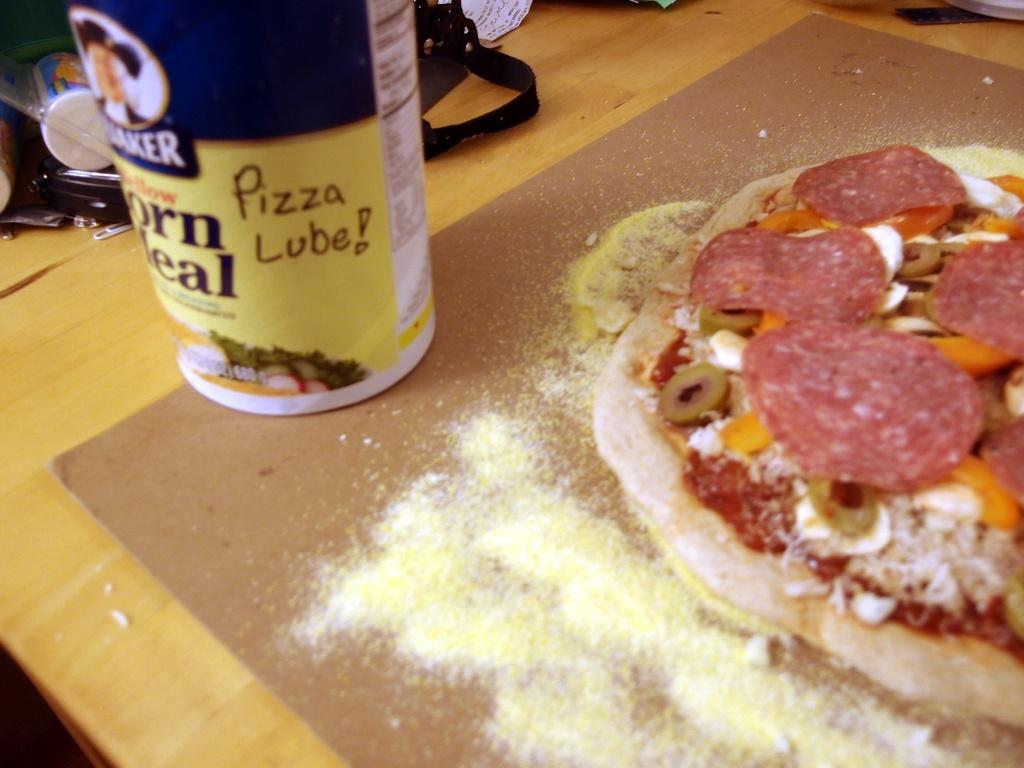What is located at the bottom of the image? There is a board at the bottom of the image. What is on top of the board? There is a pizza and a bottle on the board. Can you describe any objects visible in the background of the image? Unfortunately, the provided facts do not give any information about the objects visible in the background. How many rabbits can be seen playing with a cap in the image? There are no rabbits or caps present in the image. What type of party is being depicted in the image? There is no party depicted in the image; it features a board with a pizza and a bottle. 